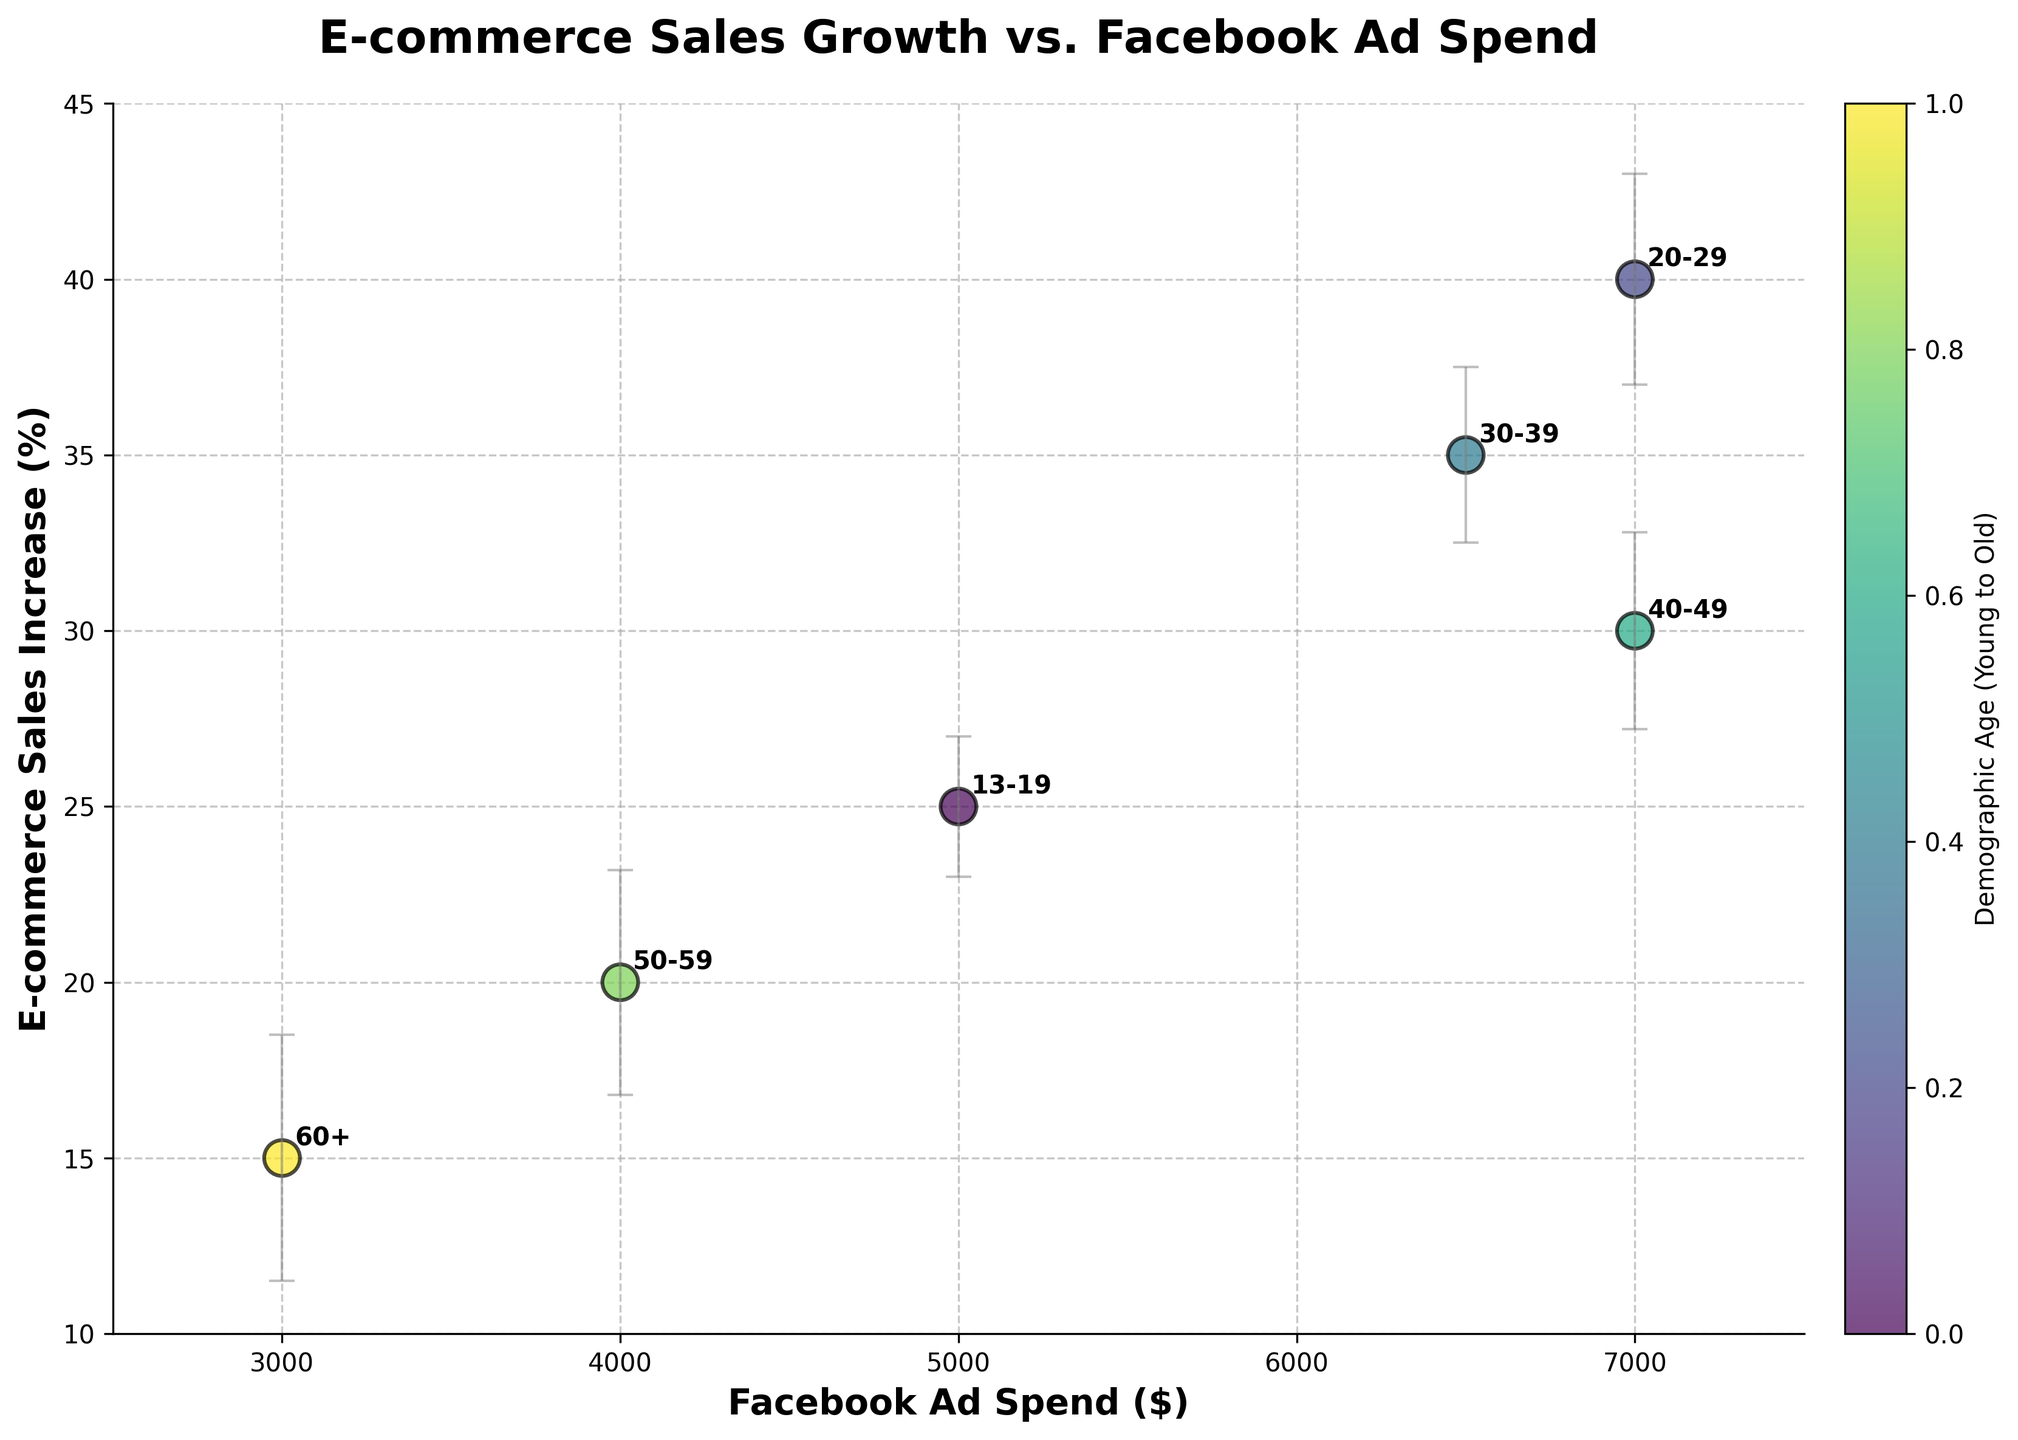What is the title of the scatter plot? The title of the scatter plot is clearly mentioned at the top of the figure.
Answer: E-commerce Sales Growth vs. Facebook Ad Spend What is the age group that spends the most on Facebook ads? By examining the x-axis values, which represent Facebook Ad Spend, we can see that the highest value is $7000, corresponding to Young Adults and Middle-aged.
Answer: Young Adults and Middle-aged How big is the e-commerce sales increase for teenagers? By looking at the y-axis value for the Teenage group label (13-19), we can determine the sales increase.
Answer: 25% Which age group has the highest e-commerce sales increase? By identifying the highest y-axis value, we can determine the age group with the maximum sales increase.
Answer: Young Adults What is the error margin for the Adults age group? The error margin values are given and can be found by looking at the group label for Adults (30-39) and checking its corresponding error.
Answer: 2.5% Which age group has the smallest increase in e-commerce sales? The smallest e-commerce sales increase can be identified by the lowest y-axis value in the scatter plot.
Answer: Elders What is the difference in Facebook Ad Spend between Teenagers and Seniors? The ad spend for Teenagers is $5000 and for Seniors is $4000. The difference can be calculated by subtracting the smaller value from the larger value.
Answer: $1000 Which age group shows a higher e-commerce sales increase: Middle-aged or Seniors? Comparing the y-axis values of the Middle-aged and Seniors groups, the one with the higher value has a higher e-commerce sales increase.
Answer: Middle-aged What is the total error margin for Elders and Seniors combined? Adding the error margins for Elders (3.5%) and Seniors (3.2%) gives the total error margin for both groups combined.
Answer: 6.7% Is there a correlation between Facebook Ad Spend and E-commerce Sales Increase? Observing the general trend or pattern in the scatter plot allows us to determine if there is a direct correlation. Although there is some correlation, it is not perfectly linear.
Answer: Positive correlation 